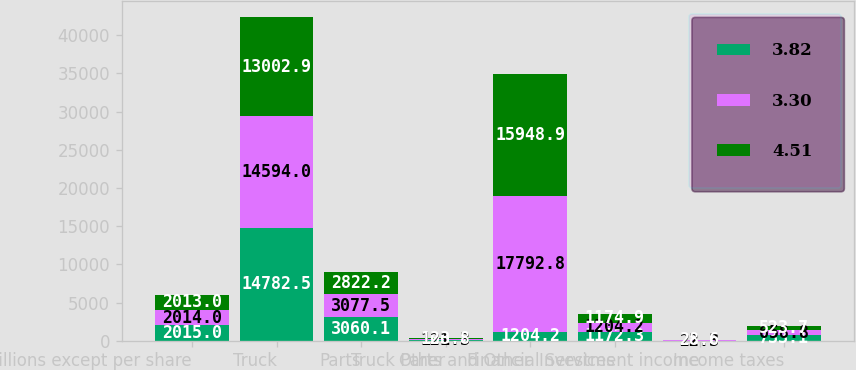Convert chart to OTSL. <chart><loc_0><loc_0><loc_500><loc_500><stacked_bar_chart><ecel><fcel>( in millions except per share<fcel>Truck<fcel>Parts<fcel>Other<fcel>Truck Parts and Other<fcel>Financial Services<fcel>Investment income<fcel>Income taxes<nl><fcel>3.82<fcel>2015<fcel>14782.5<fcel>3060.1<fcel>100.2<fcel>1204.2<fcel>1172.3<fcel>21.8<fcel>733.1<nl><fcel>3.3<fcel>2014<fcel>14594<fcel>3077.5<fcel>121.3<fcel>17792.8<fcel>1204.2<fcel>22.3<fcel>658.8<nl><fcel>4.51<fcel>2013<fcel>13002.9<fcel>2822.2<fcel>123.8<fcel>15948.9<fcel>1174.9<fcel>28.6<fcel>523.7<nl></chart> 